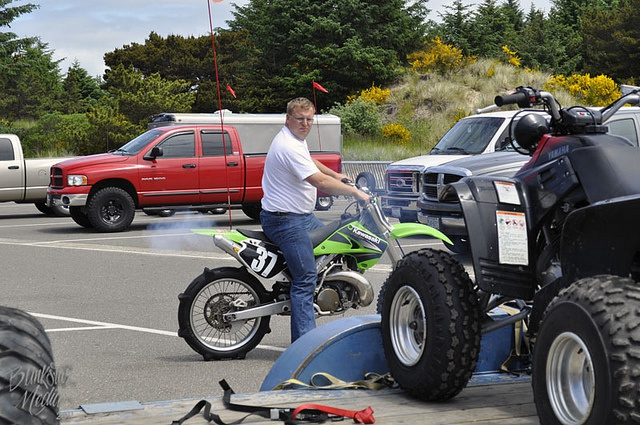Describe the objects in this image and their specific colors. I can see motorcycle in darkgreen, black, gray, darkgray, and lightgray tones, motorcycle in darkgreen, black, darkgray, gray, and lightgray tones, truck in darkgreen, black, brown, gray, and salmon tones, people in darkgreen, lavender, navy, darkgray, and black tones, and truck in darkgreen, gray, white, and darkgray tones in this image. 